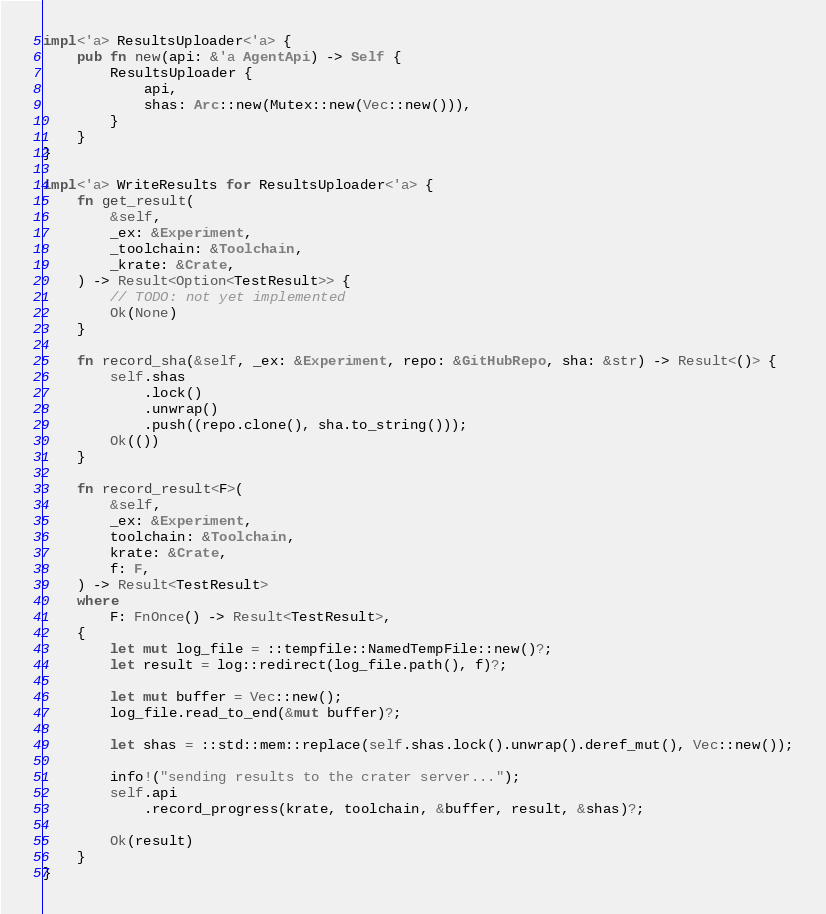Convert code to text. <code><loc_0><loc_0><loc_500><loc_500><_Rust_>
impl<'a> ResultsUploader<'a> {
    pub fn new(api: &'a AgentApi) -> Self {
        ResultsUploader {
            api,
            shas: Arc::new(Mutex::new(Vec::new())),
        }
    }
}

impl<'a> WriteResults for ResultsUploader<'a> {
    fn get_result(
        &self,
        _ex: &Experiment,
        _toolchain: &Toolchain,
        _krate: &Crate,
    ) -> Result<Option<TestResult>> {
        // TODO: not yet implemented
        Ok(None)
    }

    fn record_sha(&self, _ex: &Experiment, repo: &GitHubRepo, sha: &str) -> Result<()> {
        self.shas
            .lock()
            .unwrap()
            .push((repo.clone(), sha.to_string()));
        Ok(())
    }

    fn record_result<F>(
        &self,
        _ex: &Experiment,
        toolchain: &Toolchain,
        krate: &Crate,
        f: F,
    ) -> Result<TestResult>
    where
        F: FnOnce() -> Result<TestResult>,
    {
        let mut log_file = ::tempfile::NamedTempFile::new()?;
        let result = log::redirect(log_file.path(), f)?;

        let mut buffer = Vec::new();
        log_file.read_to_end(&mut buffer)?;

        let shas = ::std::mem::replace(self.shas.lock().unwrap().deref_mut(), Vec::new());

        info!("sending results to the crater server...");
        self.api
            .record_progress(krate, toolchain, &buffer, result, &shas)?;

        Ok(result)
    }
}
</code> 